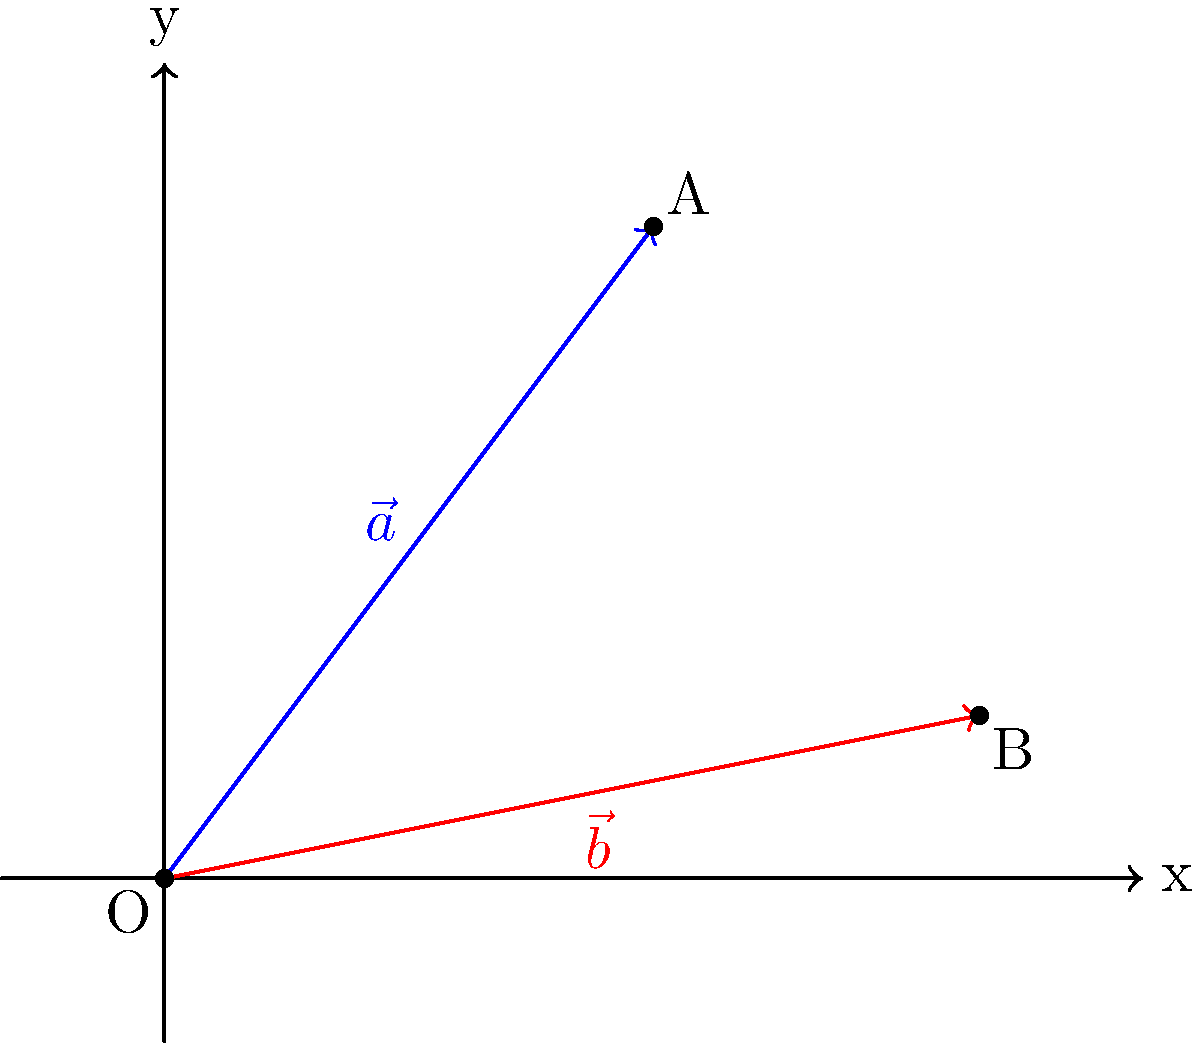In the coordinate system shown, vector $\vec{a}$ extends from the origin O to point A(3,4), and vector $\vec{b}$ extends from the origin O to point B(5,1). Calculate the angle between these two vectors to the nearest degree. To find the angle between two vectors, we can use the dot product formula:

$$\cos \theta = \frac{\vec{a} \cdot \vec{b}}{|\vec{a}| |\vec{b}|}$$

Step 1: Calculate the dot product $\vec{a} \cdot \vec{b}$
$\vec{a} \cdot \vec{b} = (3)(5) + (4)(1) = 15 + 4 = 19$

Step 2: Calculate the magnitudes of the vectors
$|\vec{a}| = \sqrt{3^2 + 4^2} = \sqrt{9 + 16} = \sqrt{25} = 5$
$|\vec{b}| = \sqrt{5^2 + 1^2} = \sqrt{25 + 1} = \sqrt{26}$

Step 3: Apply the dot product formula
$$\cos \theta = \frac{19}{5\sqrt{26}}$$

Step 4: Take the inverse cosine (arccos) of both sides
$$\theta = \arccos(\frac{19}{5\sqrt{26}})$$

Step 5: Calculate the result and round to the nearest degree
$\theta \approx 36.87°$, which rounds to 37°
Answer: 37° 